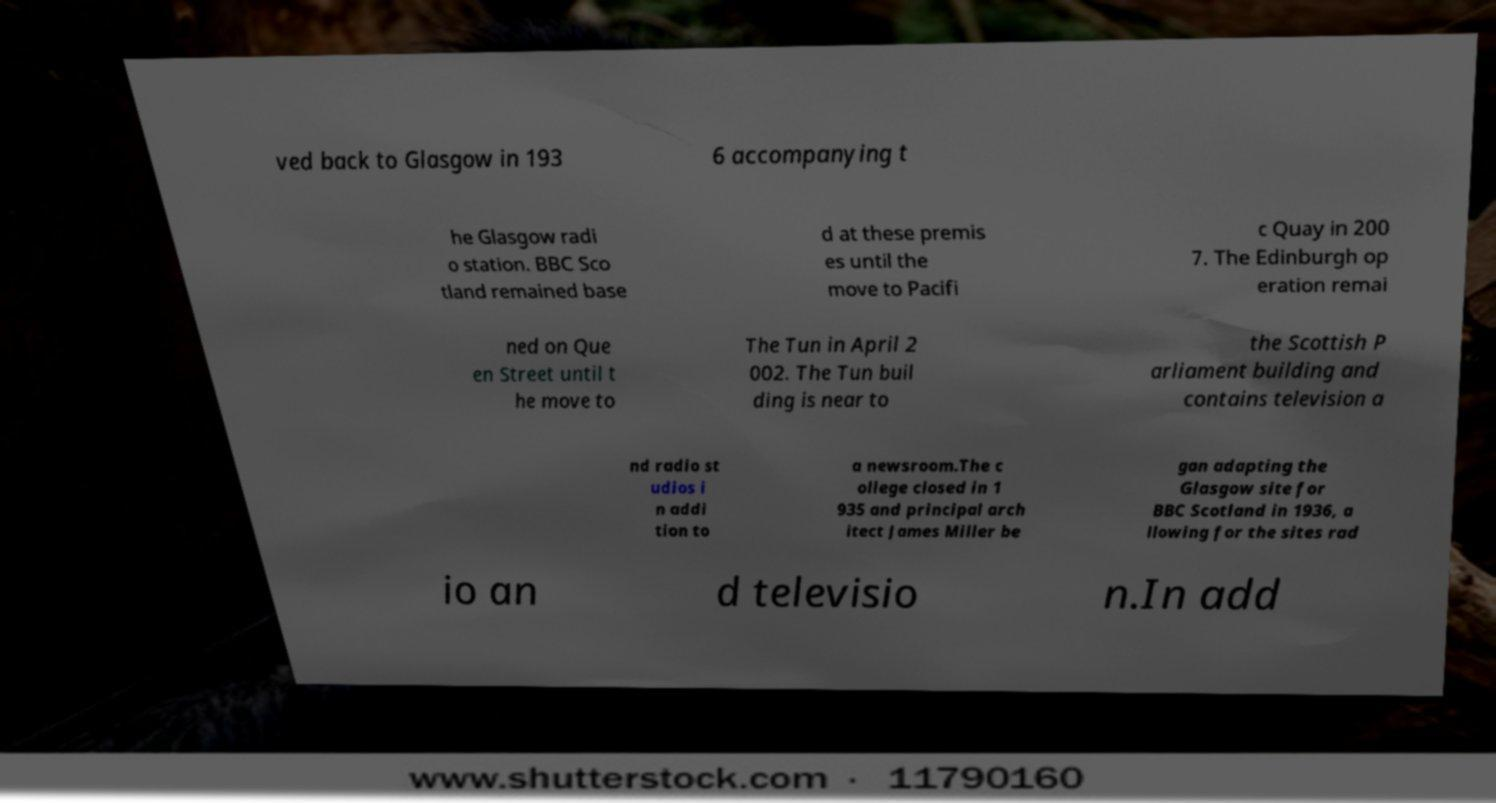Can you accurately transcribe the text from the provided image for me? ved back to Glasgow in 193 6 accompanying t he Glasgow radi o station. BBC Sco tland remained base d at these premis es until the move to Pacifi c Quay in 200 7. The Edinburgh op eration remai ned on Que en Street until t he move to The Tun in April 2 002. The Tun buil ding is near to the Scottish P arliament building and contains television a nd radio st udios i n addi tion to a newsroom.The c ollege closed in 1 935 and principal arch itect James Miller be gan adapting the Glasgow site for BBC Scotland in 1936, a llowing for the sites rad io an d televisio n.In add 